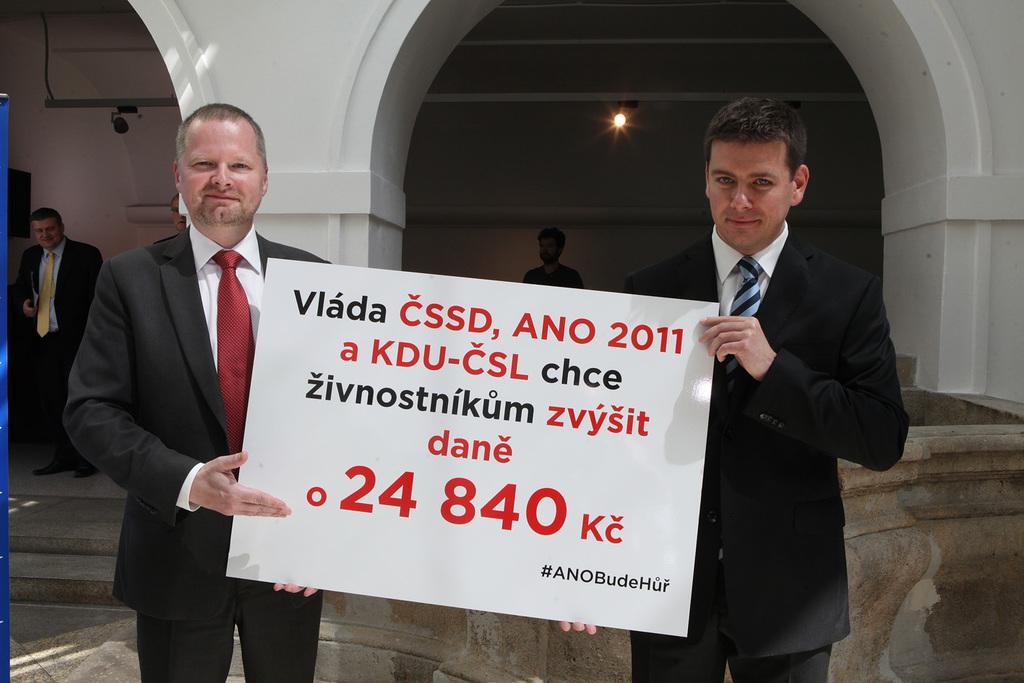Can you describe this image briefly? In this image there two people standing and they are holding board, on the board there is text. And in the background there are two people, pillars, wall, lights and objects. 